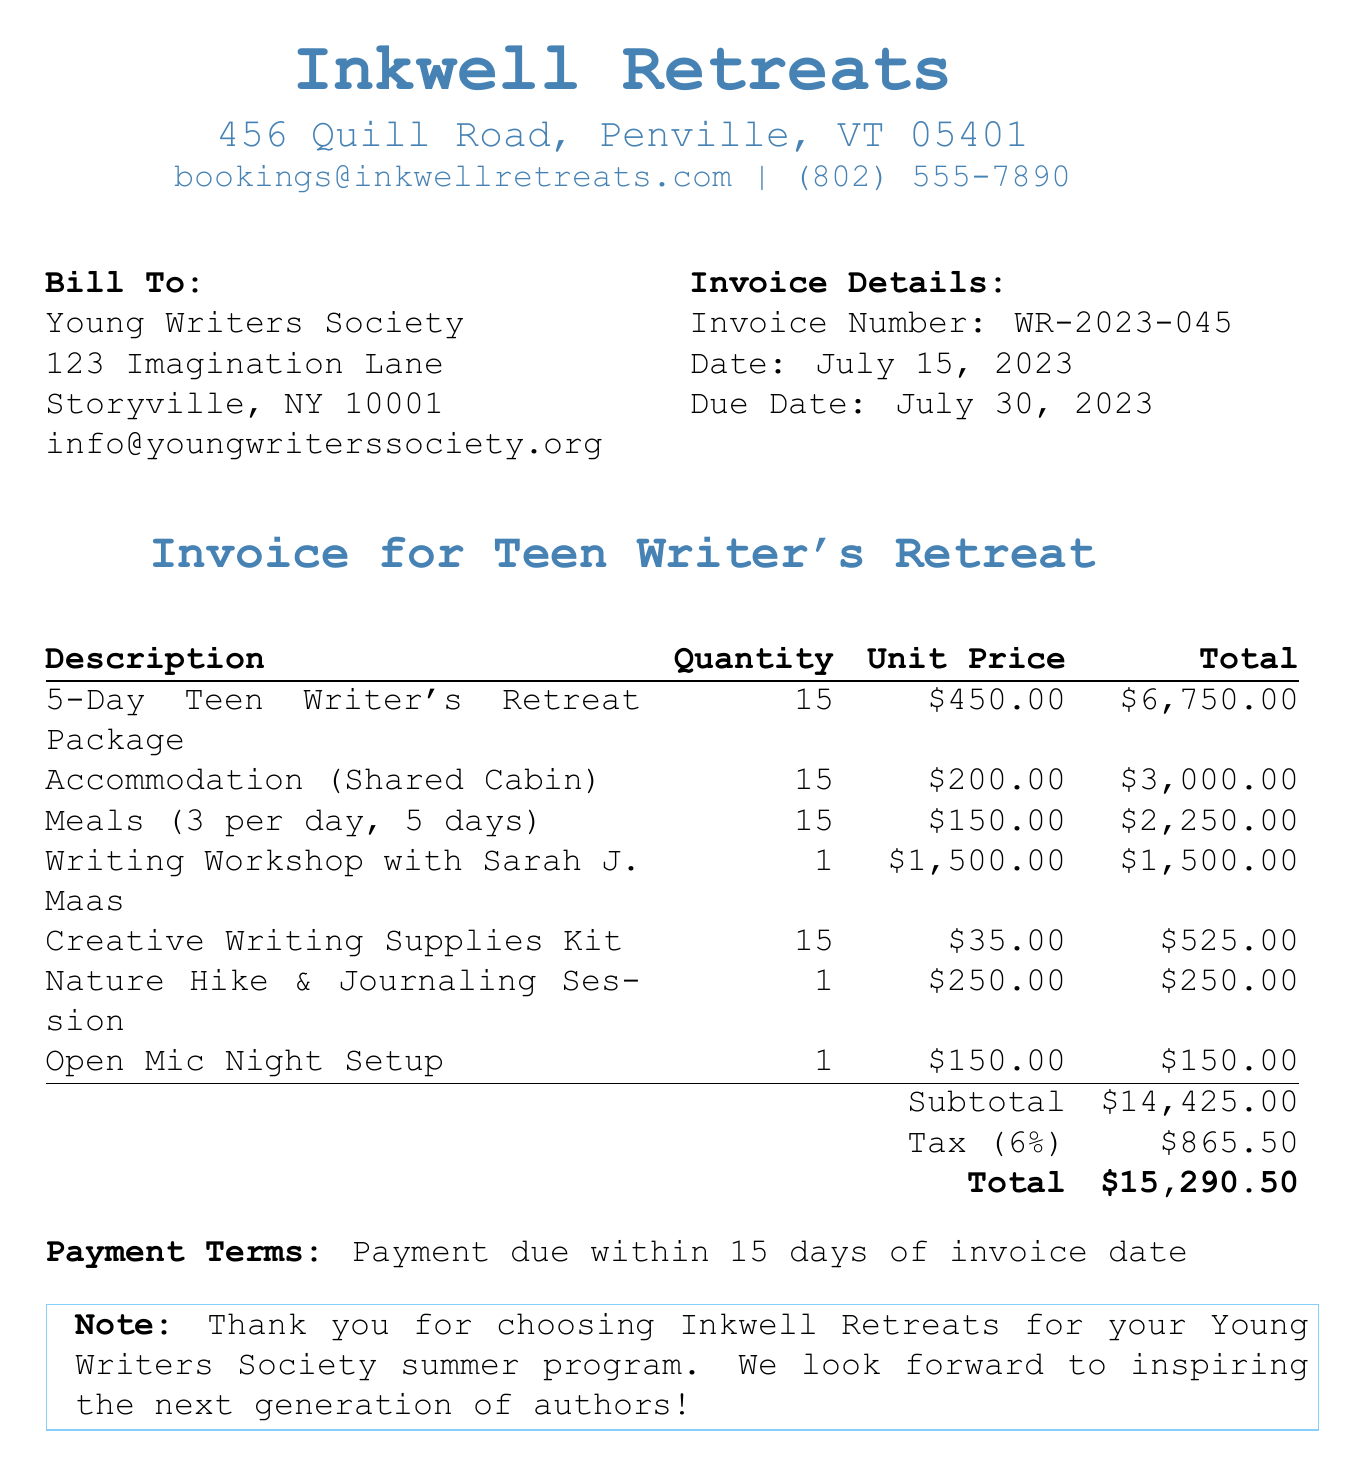What is the invoice number? The invoice number is listed at the top of the document to identify this specific invoice.
Answer: WR-2023-045 What is the due date for payment? The due date is clearly stated in the invoice details section of the document.
Answer: July 30, 2023 Who is the bill to? The invoice specifies the recipient of the bill in the "Bill To:" section.
Answer: Young Writers Society What is the total amount due? The total amount is provided at the bottom of the invoice summary, including subtotal and tax.
Answer: $15,290.50 How many participants are included in the retreat package? The quantity listed for the retreat package shows how many participants are attending the retreat.
Answer: 15 What items are included in the meals cost? The description of meals specifies what is provided over the duration of the retreat.
Answer: 3 per day, 5 days What payment terms are set for this invoice? The payment terms are noted at the end of the invoice, indicating when payment is expected.
Answer: Payment due within 15 days of invoice date What is the tax rate applied to this invoice? The tax rate is mentioned in the invoice summary alongside the subtotal and total.
Answer: 6% What writing activity is highlighted with a specified cost? The activities listed in the invoice include a special workshop with a noted author, showcasing its importance.
Answer: Writing Workshop with Sarah J. Maas 